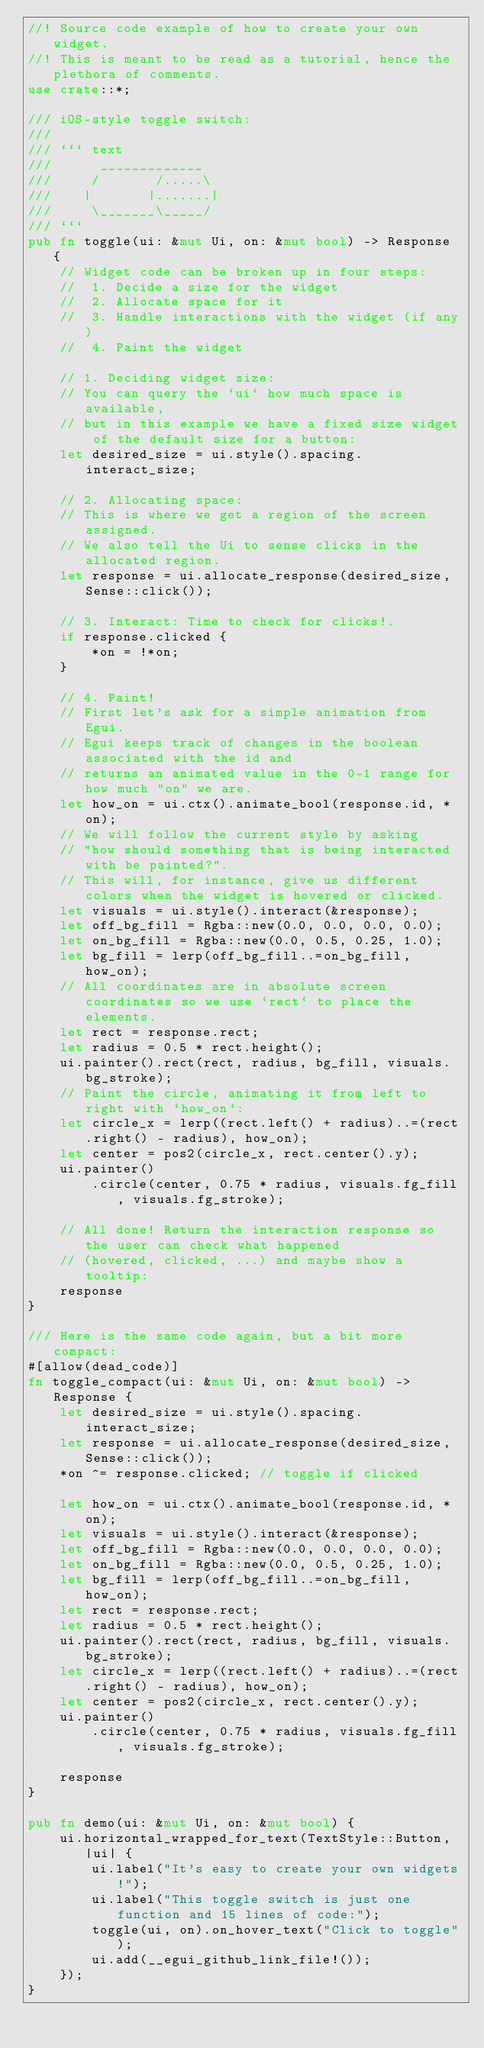Convert code to text. <code><loc_0><loc_0><loc_500><loc_500><_Rust_>//! Source code example of how to create your own widget.
//! This is meant to be read as a tutorial, hence the plethora of comments.
use crate::*;

/// iOS-style toggle switch:
///
/// ``` text
///      _____________
///     /       /.....\
///    |       |.......|
///     \_______\_____/
/// ```
pub fn toggle(ui: &mut Ui, on: &mut bool) -> Response {
    // Widget code can be broken up in four steps:
    //  1. Decide a size for the widget
    //  2. Allocate space for it
    //  3. Handle interactions with the widget (if any)
    //  4. Paint the widget

    // 1. Deciding widget size:
    // You can query the `ui` how much space is available,
    // but in this example we have a fixed size widget of the default size for a button:
    let desired_size = ui.style().spacing.interact_size;

    // 2. Allocating space:
    // This is where we get a region of the screen assigned.
    // We also tell the Ui to sense clicks in the allocated region.
    let response = ui.allocate_response(desired_size, Sense::click());

    // 3. Interact: Time to check for clicks!.
    if response.clicked {
        *on = !*on;
    }

    // 4. Paint!
    // First let's ask for a simple animation from Egui.
    // Egui keeps track of changes in the boolean associated with the id and
    // returns an animated value in the 0-1 range for how much "on" we are.
    let how_on = ui.ctx().animate_bool(response.id, *on);
    // We will follow the current style by asking
    // "how should something that is being interacted with be painted?".
    // This will, for instance, give us different colors when the widget is hovered or clicked.
    let visuals = ui.style().interact(&response);
    let off_bg_fill = Rgba::new(0.0, 0.0, 0.0, 0.0);
    let on_bg_fill = Rgba::new(0.0, 0.5, 0.25, 1.0);
    let bg_fill = lerp(off_bg_fill..=on_bg_fill, how_on);
    // All coordinates are in absolute screen coordinates so we use `rect` to place the elements.
    let rect = response.rect;
    let radius = 0.5 * rect.height();
    ui.painter().rect(rect, radius, bg_fill, visuals.bg_stroke);
    // Paint the circle, animating it from left to right with `how_on`:
    let circle_x = lerp((rect.left() + radius)..=(rect.right() - radius), how_on);
    let center = pos2(circle_x, rect.center().y);
    ui.painter()
        .circle(center, 0.75 * radius, visuals.fg_fill, visuals.fg_stroke);

    // All done! Return the interaction response so the user can check what happened
    // (hovered, clicked, ...) and maybe show a tooltip:
    response
}

/// Here is the same code again, but a bit more compact:
#[allow(dead_code)]
fn toggle_compact(ui: &mut Ui, on: &mut bool) -> Response {
    let desired_size = ui.style().spacing.interact_size;
    let response = ui.allocate_response(desired_size, Sense::click());
    *on ^= response.clicked; // toggle if clicked

    let how_on = ui.ctx().animate_bool(response.id, *on);
    let visuals = ui.style().interact(&response);
    let off_bg_fill = Rgba::new(0.0, 0.0, 0.0, 0.0);
    let on_bg_fill = Rgba::new(0.0, 0.5, 0.25, 1.0);
    let bg_fill = lerp(off_bg_fill..=on_bg_fill, how_on);
    let rect = response.rect;
    let radius = 0.5 * rect.height();
    ui.painter().rect(rect, radius, bg_fill, visuals.bg_stroke);
    let circle_x = lerp((rect.left() + radius)..=(rect.right() - radius), how_on);
    let center = pos2(circle_x, rect.center().y);
    ui.painter()
        .circle(center, 0.75 * radius, visuals.fg_fill, visuals.fg_stroke);

    response
}

pub fn demo(ui: &mut Ui, on: &mut bool) {
    ui.horizontal_wrapped_for_text(TextStyle::Button, |ui| {
        ui.label("It's easy to create your own widgets!");
        ui.label("This toggle switch is just one function and 15 lines of code:");
        toggle(ui, on).on_hover_text("Click to toggle");
        ui.add(__egui_github_link_file!());
    });
}
</code> 